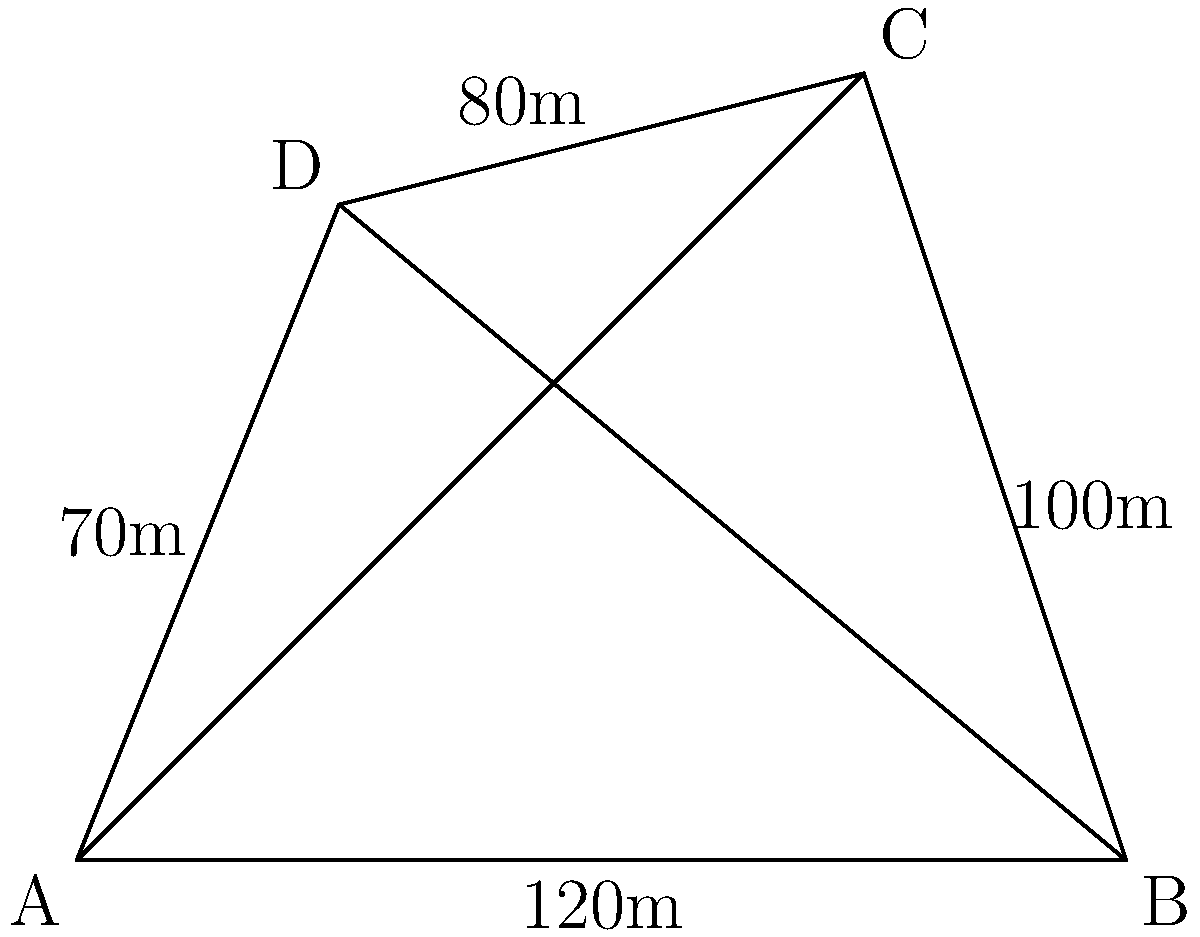As a therapy horseback riding instructor, you need to calculate the area of an irregularly shaped pasture for your riding sessions. The pasture is represented by the quadrilateral ABCD in the diagram. Given that AB = 120m, BC = 100m, CD = 80m, and DA = 70m, calculate the total area of the pasture using the triangulation method. To calculate the area of the irregularly shaped pasture, we'll use the triangulation method by dividing the quadrilateral into two triangles and calculating their areas separately.

Step 1: Divide the quadrilateral into two triangles by drawing the diagonal AC.

Step 2: Calculate the semi-perimeter (s) of triangle ABC:
$s_{ABC} = \frac{AB + BC + AC}{2}$

Step 3: Use Heron's formula to calculate the area of triangle ABC:
$Area_{ABC} = \sqrt{s(s-AB)(s-BC)(s-AC)}$

Step 4: Calculate the semi-perimeter (s) of triangle ACD:
$s_{ACD} = \frac{AC + CD + DA}{2}$

Step 5: Use Heron's formula to calculate the area of triangle ACD:
$Area_{ACD} = \sqrt{s(s-AC)(s-CD)(s-DA)}$

Step 6: Calculate the length of diagonal AC using the Pythagorean theorem:
$AC = \sqrt{AB^2 + BC^2} = \sqrt{120^2 + 100^2} = 156.2$ m

Step 7: Calculate the area of triangle ABC:
$s_{ABC} = \frac{120 + 100 + 156.2}{2} = 188.1$ m
$Area_{ABC} = \sqrt{188.1(188.1-120)(188.1-100)(188.1-156.2)} = 5400$ m²

Step 8: Calculate the area of triangle ACD:
$s_{ACD} = \frac{156.2 + 80 + 70}{2} = 153.1$ m
$Area_{ACD} = \sqrt{153.1(153.1-156.2)(153.1-80)(153.1-70)} = 2700$ m²

Step 9: Calculate the total area of the pasture by adding the areas of both triangles:
$Area_{total} = Area_{ABC} + Area_{ACD} = 5400 + 2700 = 8100$ m²
Answer: 8100 m² 